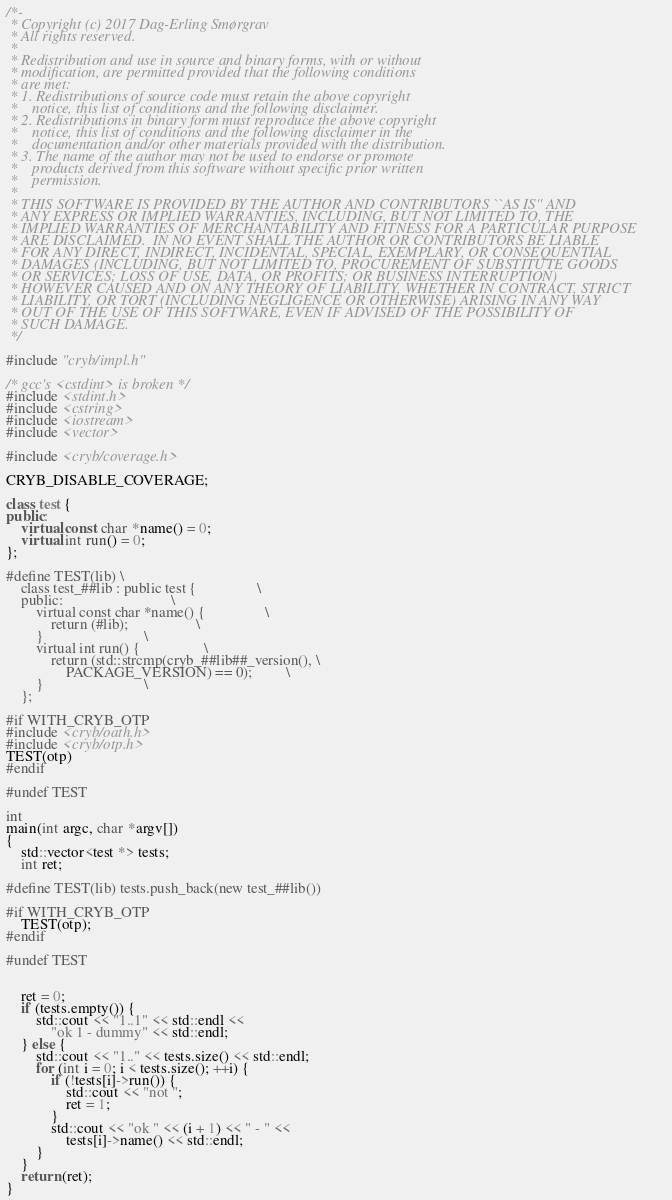Convert code to text. <code><loc_0><loc_0><loc_500><loc_500><_C++_>/*-
 * Copyright (c) 2017 Dag-Erling Smørgrav
 * All rights reserved.
 *
 * Redistribution and use in source and binary forms, with or without
 * modification, are permitted provided that the following conditions
 * are met:
 * 1. Redistributions of source code must retain the above copyright
 *    notice, this list of conditions and the following disclaimer.
 * 2. Redistributions in binary form must reproduce the above copyright
 *    notice, this list of conditions and the following disclaimer in the
 *    documentation and/or other materials provided with the distribution.
 * 3. The name of the author may not be used to endorse or promote
 *    products derived from this software without specific prior written
 *    permission.
 *
 * THIS SOFTWARE IS PROVIDED BY THE AUTHOR AND CONTRIBUTORS ``AS IS'' AND
 * ANY EXPRESS OR IMPLIED WARRANTIES, INCLUDING, BUT NOT LIMITED TO, THE
 * IMPLIED WARRANTIES OF MERCHANTABILITY AND FITNESS FOR A PARTICULAR PURPOSE
 * ARE DISCLAIMED.  IN NO EVENT SHALL THE AUTHOR OR CONTRIBUTORS BE LIABLE
 * FOR ANY DIRECT, INDIRECT, INCIDENTAL, SPECIAL, EXEMPLARY, OR CONSEQUENTIAL
 * DAMAGES (INCLUDING, BUT NOT LIMITED TO, PROCUREMENT OF SUBSTITUTE GOODS
 * OR SERVICES; LOSS OF USE, DATA, OR PROFITS; OR BUSINESS INTERRUPTION)
 * HOWEVER CAUSED AND ON ANY THEORY OF LIABILITY, WHETHER IN CONTRACT, STRICT
 * LIABILITY, OR TORT (INCLUDING NEGLIGENCE OR OTHERWISE) ARISING IN ANY WAY
 * OUT OF THE USE OF THIS SOFTWARE, EVEN IF ADVISED OF THE POSSIBILITY OF
 * SUCH DAMAGE.
 */

#include "cryb/impl.h"

/* gcc's <cstdint> is broken */
#include <stdint.h>
#include <cstring>
#include <iostream>
#include <vector>

#include <cryb/coverage.h>

CRYB_DISABLE_COVERAGE;

class test {
public:
	virtual const char *name() = 0;
	virtual int run() = 0;
};

#define TEST(lib) \
	class test_##lib : public test {				\
	public:								\
		virtual const char *name() {				\
			return (#lib);					\
		}							\
		virtual int run() {					\
			return (std::strcmp(cryb_##lib##_version(),	\
			    PACKAGE_VERSION) == 0);			\
		}							\
	};

#if WITH_CRYB_OTP
#include <cryb/oath.h>
#include <cryb/otp.h>
TEST(otp)
#endif

#undef TEST

int
main(int argc, char *argv[])
{
	std::vector<test *> tests;
	int ret;

#define TEST(lib) tests.push_back(new test_##lib())

#if WITH_CRYB_OTP
	TEST(otp);
#endif

#undef TEST


	ret = 0;
	if (tests.empty()) {
		std::cout << "1..1" << std::endl <<
		    "ok 1 - dummy" << std::endl;
	} else {
		std::cout << "1.." << tests.size() << std::endl;
		for (int i = 0; i < tests.size(); ++i) {
			if (!tests[i]->run()) {
				std::cout << "not ";
				ret = 1;
			}
			std::cout << "ok " << (i + 1) << " - " <<
			    tests[i]->name() << std::endl;
		}
	}
	return (ret);
}
</code> 